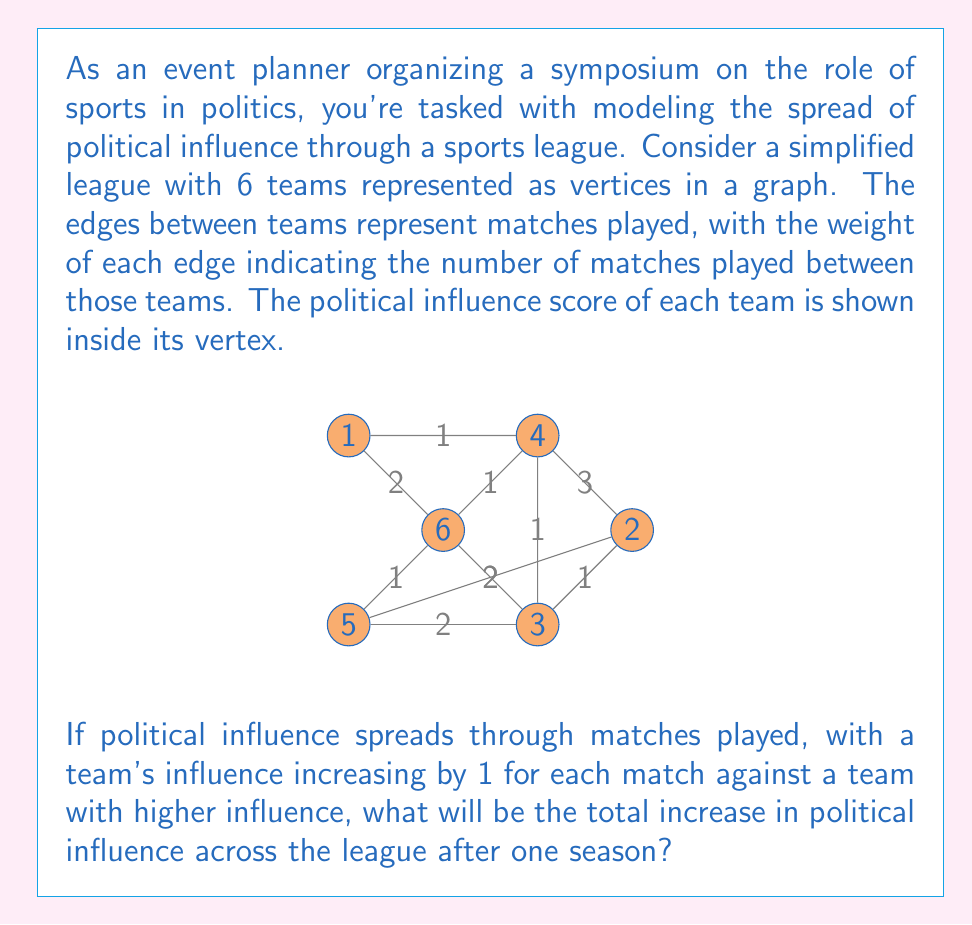Provide a solution to this math problem. To solve this problem, we need to follow these steps:

1) First, let's identify all the edges where influence will spread. This occurs when a team with lower influence plays against a team with higher influence.

2) For each such edge, we need to multiply the weight of the edge (number of matches) by the number of teams that will gain influence.

3) Let's go through each edge:

   A-B: A(5) > B(3), 2 matches, B gains 2 influence
   A-C: A(5) > C(2), 2 matches, C gains 2 influence
   A-E: A(5) > E(1), 2 matches, E gains 2 influence
   A-F: A(5) < F(6), 1 match, A gains 1 influence
   B-C: B(3) > C(2), 1 match, C gains 1 influence
   B-D: B(3) < D(4), 1 match, B gains 1 influence
   B-F: B(3) < F(6), 2 matches, B gains 2 influence
   C-D: C(2) < D(4), 3 matches, C gains 3 influence
   D-E: D(4) > E(1), 1 match, E gains 1 influence
   D-F: D(4) < F(6), 1 match, D gains 1 influence
   E-F: E(1) < F(6), 2 matches, E gains 2 influence

4) Now, let's sum up all the gains:
   
   $$2 + 2 + 2 + 1 + 1 + 1 + 2 + 3 + 1 + 1 + 2 = 18$$

Therefore, the total increase in political influence across the league after one season is 18.
Answer: 18 